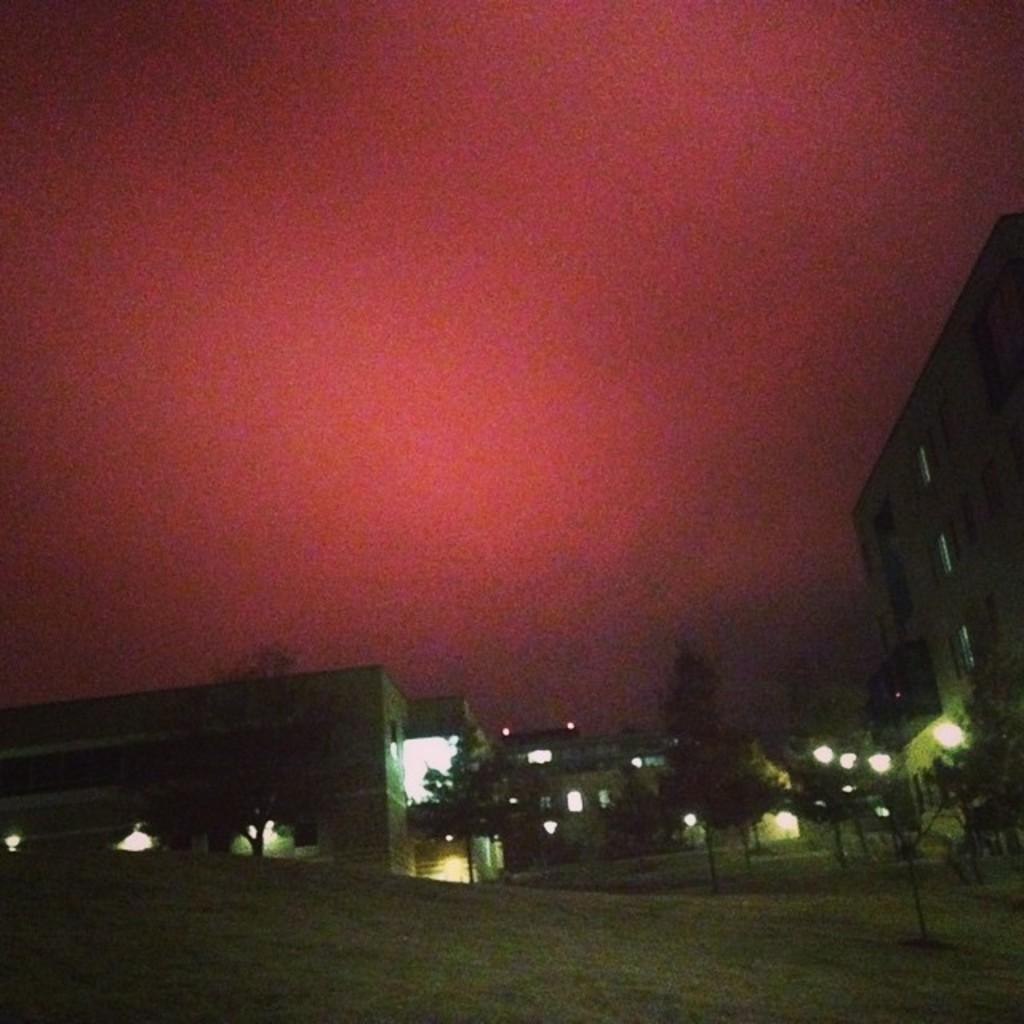What type of structures can be seen in the image? There are buildings in the image. What else can be seen in the image besides buildings? There are poles, lights, and trees in the image. What scientific discoveries are being made in the image? There is no indication of scientific discoveries being made in the image. What mode of transport is visible in the image? There is no mode of transport visible in the image. 